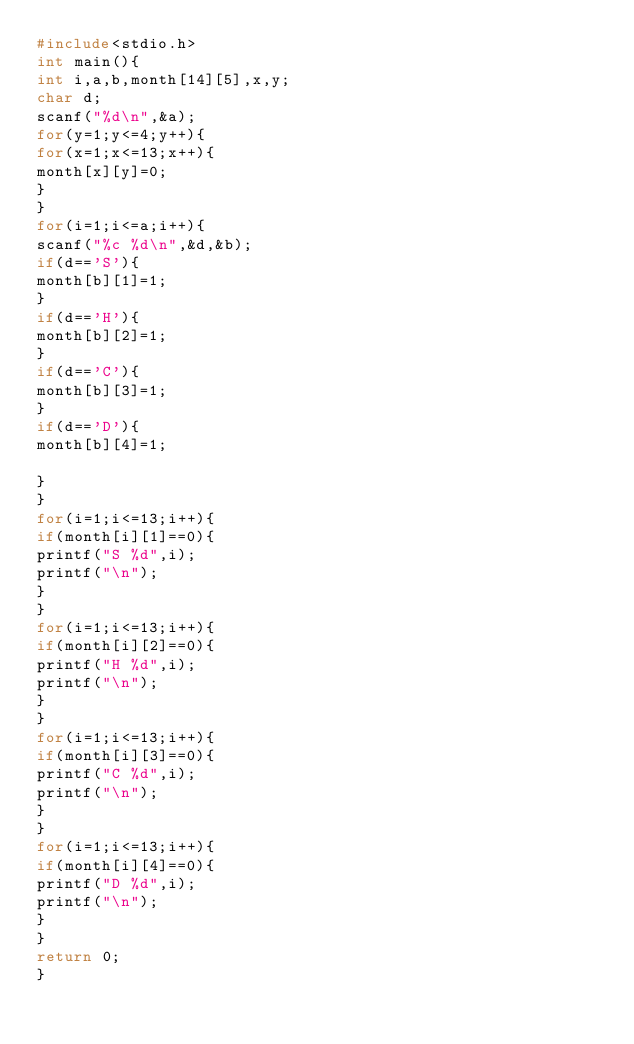<code> <loc_0><loc_0><loc_500><loc_500><_C_>#include<stdio.h>
int main(){
int i,a,b,month[14][5],x,y;
char d;
scanf("%d\n",&a);
for(y=1;y<=4;y++){
for(x=1;x<=13;x++){
month[x][y]=0;
}
}
for(i=1;i<=a;i++){
scanf("%c %d\n",&d,&b);
if(d=='S'){
month[b][1]=1;
}
if(d=='H'){
month[b][2]=1;
}
if(d=='C'){
month[b][3]=1;
}
if(d=='D'){
month[b][4]=1;

}
}
for(i=1;i<=13;i++){
if(month[i][1]==0){
printf("S %d",i);
printf("\n");
}
}
for(i=1;i<=13;i++){
if(month[i][2]==0){
printf("H %d",i);
printf("\n");
}
}
for(i=1;i<=13;i++){
if(month[i][3]==0){
printf("C %d",i);
printf("\n");
}
}
for(i=1;i<=13;i++){
if(month[i][4]==0){
printf("D %d",i);
printf("\n");
}
}
return 0;
}
</code> 